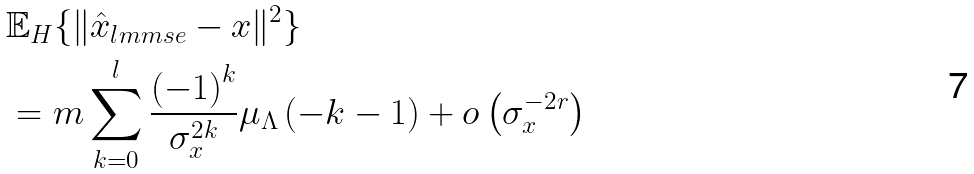Convert formula to latex. <formula><loc_0><loc_0><loc_500><loc_500>& \mathbb { E } _ { H } \{ \| \hat { x } _ { l m m s e } - x \| ^ { 2 } \} \\ & = m \sum _ { k = 0 } ^ { l } \frac { \left ( - 1 \right ) ^ { k } } { \sigma _ { x } ^ { 2 k } } \mu _ { \Lambda } \left ( - k - 1 \right ) + o \left ( \sigma _ { x } ^ { - 2 r } \right )</formula> 